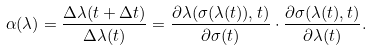<formula> <loc_0><loc_0><loc_500><loc_500>\alpha ( \lambda ) = \frac { \Delta \lambda ( t + \Delta t ) } { \Delta \lambda ( t ) } = \frac { \partial \lambda ( \sigma ( \lambda ( t ) ) , t ) } { \partial \sigma ( t ) } \cdot \frac { \partial \sigma ( \lambda ( t ) , t ) } { \partial \lambda ( t ) } .</formula> 